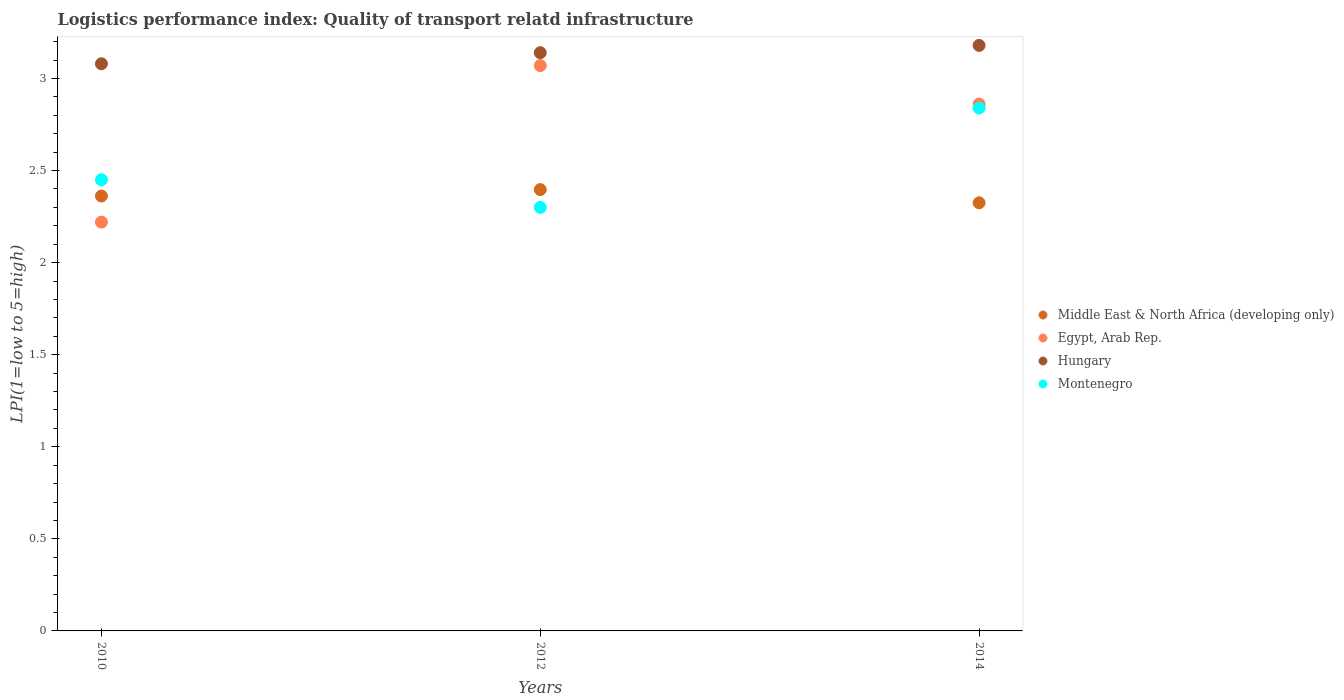How many different coloured dotlines are there?
Keep it short and to the point. 4. What is the logistics performance index in Hungary in 2010?
Provide a short and direct response. 3.08. Across all years, what is the maximum logistics performance index in Montenegro?
Offer a very short reply. 2.84. Across all years, what is the minimum logistics performance index in Middle East & North Africa (developing only)?
Provide a short and direct response. 2.32. In which year was the logistics performance index in Egypt, Arab Rep. minimum?
Your answer should be compact. 2010. What is the total logistics performance index in Hungary in the graph?
Ensure brevity in your answer.  9.4. What is the difference between the logistics performance index in Middle East & North Africa (developing only) in 2010 and that in 2012?
Keep it short and to the point. -0.03. What is the difference between the logistics performance index in Hungary in 2012 and the logistics performance index in Middle East & North Africa (developing only) in 2010?
Your answer should be very brief. 0.78. What is the average logistics performance index in Middle East & North Africa (developing only) per year?
Your answer should be very brief. 2.36. In the year 2010, what is the difference between the logistics performance index in Montenegro and logistics performance index in Egypt, Arab Rep.?
Offer a very short reply. 0.23. In how many years, is the logistics performance index in Montenegro greater than 1.7?
Your answer should be very brief. 3. What is the ratio of the logistics performance index in Montenegro in 2012 to that in 2014?
Ensure brevity in your answer.  0.81. Is the logistics performance index in Hungary in 2012 less than that in 2014?
Your answer should be very brief. Yes. Is the difference between the logistics performance index in Montenegro in 2012 and 2014 greater than the difference between the logistics performance index in Egypt, Arab Rep. in 2012 and 2014?
Ensure brevity in your answer.  No. What is the difference between the highest and the second highest logistics performance index in Hungary?
Keep it short and to the point. 0.04. What is the difference between the highest and the lowest logistics performance index in Montenegro?
Offer a terse response. 0.54. In how many years, is the logistics performance index in Middle East & North Africa (developing only) greater than the average logistics performance index in Middle East & North Africa (developing only) taken over all years?
Ensure brevity in your answer.  2. Does the logistics performance index in Middle East & North Africa (developing only) monotonically increase over the years?
Provide a short and direct response. No. Is the logistics performance index in Hungary strictly greater than the logistics performance index in Montenegro over the years?
Ensure brevity in your answer.  Yes. Is the logistics performance index in Hungary strictly less than the logistics performance index in Egypt, Arab Rep. over the years?
Your answer should be compact. No. How many years are there in the graph?
Ensure brevity in your answer.  3. Does the graph contain grids?
Provide a succinct answer. No. How are the legend labels stacked?
Provide a succinct answer. Vertical. What is the title of the graph?
Your response must be concise. Logistics performance index: Quality of transport relatd infrastructure. Does "Czech Republic" appear as one of the legend labels in the graph?
Your response must be concise. No. What is the label or title of the Y-axis?
Your answer should be compact. LPI(1=low to 5=high). What is the LPI(1=low to 5=high) in Middle East & North Africa (developing only) in 2010?
Your answer should be very brief. 2.36. What is the LPI(1=low to 5=high) of Egypt, Arab Rep. in 2010?
Your answer should be very brief. 2.22. What is the LPI(1=low to 5=high) in Hungary in 2010?
Make the answer very short. 3.08. What is the LPI(1=low to 5=high) of Montenegro in 2010?
Provide a short and direct response. 2.45. What is the LPI(1=low to 5=high) of Middle East & North Africa (developing only) in 2012?
Provide a succinct answer. 2.4. What is the LPI(1=low to 5=high) in Egypt, Arab Rep. in 2012?
Your response must be concise. 3.07. What is the LPI(1=low to 5=high) of Hungary in 2012?
Provide a succinct answer. 3.14. What is the LPI(1=low to 5=high) of Montenegro in 2012?
Your answer should be compact. 2.3. What is the LPI(1=low to 5=high) of Middle East & North Africa (developing only) in 2014?
Provide a short and direct response. 2.32. What is the LPI(1=low to 5=high) of Egypt, Arab Rep. in 2014?
Provide a short and direct response. 2.86. What is the LPI(1=low to 5=high) in Hungary in 2014?
Your answer should be compact. 3.18. What is the LPI(1=low to 5=high) of Montenegro in 2014?
Offer a very short reply. 2.84. Across all years, what is the maximum LPI(1=low to 5=high) in Middle East & North Africa (developing only)?
Offer a terse response. 2.4. Across all years, what is the maximum LPI(1=low to 5=high) in Egypt, Arab Rep.?
Give a very brief answer. 3.07. Across all years, what is the maximum LPI(1=low to 5=high) of Hungary?
Make the answer very short. 3.18. Across all years, what is the maximum LPI(1=low to 5=high) of Montenegro?
Your answer should be very brief. 2.84. Across all years, what is the minimum LPI(1=low to 5=high) of Middle East & North Africa (developing only)?
Offer a terse response. 2.32. Across all years, what is the minimum LPI(1=low to 5=high) in Egypt, Arab Rep.?
Provide a succinct answer. 2.22. Across all years, what is the minimum LPI(1=low to 5=high) in Hungary?
Offer a very short reply. 3.08. What is the total LPI(1=low to 5=high) of Middle East & North Africa (developing only) in the graph?
Offer a very short reply. 7.08. What is the total LPI(1=low to 5=high) of Egypt, Arab Rep. in the graph?
Give a very brief answer. 8.15. What is the total LPI(1=low to 5=high) in Hungary in the graph?
Your answer should be compact. 9.4. What is the total LPI(1=low to 5=high) of Montenegro in the graph?
Offer a very short reply. 7.59. What is the difference between the LPI(1=low to 5=high) of Middle East & North Africa (developing only) in 2010 and that in 2012?
Offer a terse response. -0.03. What is the difference between the LPI(1=low to 5=high) of Egypt, Arab Rep. in 2010 and that in 2012?
Keep it short and to the point. -0.85. What is the difference between the LPI(1=low to 5=high) in Hungary in 2010 and that in 2012?
Provide a succinct answer. -0.06. What is the difference between the LPI(1=low to 5=high) of Montenegro in 2010 and that in 2012?
Your response must be concise. 0.15. What is the difference between the LPI(1=low to 5=high) of Middle East & North Africa (developing only) in 2010 and that in 2014?
Your answer should be very brief. 0.04. What is the difference between the LPI(1=low to 5=high) in Egypt, Arab Rep. in 2010 and that in 2014?
Your response must be concise. -0.64. What is the difference between the LPI(1=low to 5=high) in Hungary in 2010 and that in 2014?
Offer a very short reply. -0.1. What is the difference between the LPI(1=low to 5=high) in Montenegro in 2010 and that in 2014?
Keep it short and to the point. -0.39. What is the difference between the LPI(1=low to 5=high) in Middle East & North Africa (developing only) in 2012 and that in 2014?
Give a very brief answer. 0.07. What is the difference between the LPI(1=low to 5=high) of Egypt, Arab Rep. in 2012 and that in 2014?
Ensure brevity in your answer.  0.21. What is the difference between the LPI(1=low to 5=high) of Hungary in 2012 and that in 2014?
Keep it short and to the point. -0.04. What is the difference between the LPI(1=low to 5=high) of Montenegro in 2012 and that in 2014?
Provide a succinct answer. -0.54. What is the difference between the LPI(1=low to 5=high) of Middle East & North Africa (developing only) in 2010 and the LPI(1=low to 5=high) of Egypt, Arab Rep. in 2012?
Offer a very short reply. -0.71. What is the difference between the LPI(1=low to 5=high) in Middle East & North Africa (developing only) in 2010 and the LPI(1=low to 5=high) in Hungary in 2012?
Keep it short and to the point. -0.78. What is the difference between the LPI(1=low to 5=high) of Middle East & North Africa (developing only) in 2010 and the LPI(1=low to 5=high) of Montenegro in 2012?
Provide a short and direct response. 0.06. What is the difference between the LPI(1=low to 5=high) in Egypt, Arab Rep. in 2010 and the LPI(1=low to 5=high) in Hungary in 2012?
Offer a terse response. -0.92. What is the difference between the LPI(1=low to 5=high) of Egypt, Arab Rep. in 2010 and the LPI(1=low to 5=high) of Montenegro in 2012?
Your answer should be compact. -0.08. What is the difference between the LPI(1=low to 5=high) of Hungary in 2010 and the LPI(1=low to 5=high) of Montenegro in 2012?
Provide a short and direct response. 0.78. What is the difference between the LPI(1=low to 5=high) of Middle East & North Africa (developing only) in 2010 and the LPI(1=low to 5=high) of Egypt, Arab Rep. in 2014?
Make the answer very short. -0.5. What is the difference between the LPI(1=low to 5=high) of Middle East & North Africa (developing only) in 2010 and the LPI(1=low to 5=high) of Hungary in 2014?
Provide a short and direct response. -0.82. What is the difference between the LPI(1=low to 5=high) in Middle East & North Africa (developing only) in 2010 and the LPI(1=low to 5=high) in Montenegro in 2014?
Give a very brief answer. -0.48. What is the difference between the LPI(1=low to 5=high) in Egypt, Arab Rep. in 2010 and the LPI(1=low to 5=high) in Hungary in 2014?
Keep it short and to the point. -0.96. What is the difference between the LPI(1=low to 5=high) of Egypt, Arab Rep. in 2010 and the LPI(1=low to 5=high) of Montenegro in 2014?
Make the answer very short. -0.62. What is the difference between the LPI(1=low to 5=high) of Hungary in 2010 and the LPI(1=low to 5=high) of Montenegro in 2014?
Provide a short and direct response. 0.24. What is the difference between the LPI(1=low to 5=high) in Middle East & North Africa (developing only) in 2012 and the LPI(1=low to 5=high) in Egypt, Arab Rep. in 2014?
Offer a terse response. -0.46. What is the difference between the LPI(1=low to 5=high) of Middle East & North Africa (developing only) in 2012 and the LPI(1=low to 5=high) of Hungary in 2014?
Offer a terse response. -0.78. What is the difference between the LPI(1=low to 5=high) in Middle East & North Africa (developing only) in 2012 and the LPI(1=low to 5=high) in Montenegro in 2014?
Make the answer very short. -0.44. What is the difference between the LPI(1=low to 5=high) in Egypt, Arab Rep. in 2012 and the LPI(1=low to 5=high) in Hungary in 2014?
Offer a terse response. -0.11. What is the difference between the LPI(1=low to 5=high) in Egypt, Arab Rep. in 2012 and the LPI(1=low to 5=high) in Montenegro in 2014?
Your response must be concise. 0.23. What is the difference between the LPI(1=low to 5=high) of Hungary in 2012 and the LPI(1=low to 5=high) of Montenegro in 2014?
Your answer should be compact. 0.3. What is the average LPI(1=low to 5=high) in Middle East & North Africa (developing only) per year?
Give a very brief answer. 2.36. What is the average LPI(1=low to 5=high) in Egypt, Arab Rep. per year?
Your response must be concise. 2.72. What is the average LPI(1=low to 5=high) of Hungary per year?
Offer a very short reply. 3.13. What is the average LPI(1=low to 5=high) in Montenegro per year?
Your answer should be compact. 2.53. In the year 2010, what is the difference between the LPI(1=low to 5=high) of Middle East & North Africa (developing only) and LPI(1=low to 5=high) of Egypt, Arab Rep.?
Your answer should be compact. 0.14. In the year 2010, what is the difference between the LPI(1=low to 5=high) of Middle East & North Africa (developing only) and LPI(1=low to 5=high) of Hungary?
Your answer should be compact. -0.72. In the year 2010, what is the difference between the LPI(1=low to 5=high) of Middle East & North Africa (developing only) and LPI(1=low to 5=high) of Montenegro?
Offer a very short reply. -0.09. In the year 2010, what is the difference between the LPI(1=low to 5=high) in Egypt, Arab Rep. and LPI(1=low to 5=high) in Hungary?
Ensure brevity in your answer.  -0.86. In the year 2010, what is the difference between the LPI(1=low to 5=high) in Egypt, Arab Rep. and LPI(1=low to 5=high) in Montenegro?
Give a very brief answer. -0.23. In the year 2010, what is the difference between the LPI(1=low to 5=high) in Hungary and LPI(1=low to 5=high) in Montenegro?
Provide a succinct answer. 0.63. In the year 2012, what is the difference between the LPI(1=low to 5=high) in Middle East & North Africa (developing only) and LPI(1=low to 5=high) in Egypt, Arab Rep.?
Keep it short and to the point. -0.67. In the year 2012, what is the difference between the LPI(1=low to 5=high) of Middle East & North Africa (developing only) and LPI(1=low to 5=high) of Hungary?
Offer a very short reply. -0.74. In the year 2012, what is the difference between the LPI(1=low to 5=high) in Middle East & North Africa (developing only) and LPI(1=low to 5=high) in Montenegro?
Provide a short and direct response. 0.1. In the year 2012, what is the difference between the LPI(1=low to 5=high) in Egypt, Arab Rep. and LPI(1=low to 5=high) in Hungary?
Make the answer very short. -0.07. In the year 2012, what is the difference between the LPI(1=low to 5=high) in Egypt, Arab Rep. and LPI(1=low to 5=high) in Montenegro?
Offer a very short reply. 0.77. In the year 2012, what is the difference between the LPI(1=low to 5=high) in Hungary and LPI(1=low to 5=high) in Montenegro?
Ensure brevity in your answer.  0.84. In the year 2014, what is the difference between the LPI(1=low to 5=high) in Middle East & North Africa (developing only) and LPI(1=low to 5=high) in Egypt, Arab Rep.?
Your answer should be compact. -0.54. In the year 2014, what is the difference between the LPI(1=low to 5=high) of Middle East & North Africa (developing only) and LPI(1=low to 5=high) of Hungary?
Your answer should be compact. -0.85. In the year 2014, what is the difference between the LPI(1=low to 5=high) of Middle East & North Africa (developing only) and LPI(1=low to 5=high) of Montenegro?
Make the answer very short. -0.51. In the year 2014, what is the difference between the LPI(1=low to 5=high) of Egypt, Arab Rep. and LPI(1=low to 5=high) of Hungary?
Give a very brief answer. -0.32. In the year 2014, what is the difference between the LPI(1=low to 5=high) in Egypt, Arab Rep. and LPI(1=low to 5=high) in Montenegro?
Your answer should be very brief. 0.02. In the year 2014, what is the difference between the LPI(1=low to 5=high) in Hungary and LPI(1=low to 5=high) in Montenegro?
Ensure brevity in your answer.  0.34. What is the ratio of the LPI(1=low to 5=high) of Middle East & North Africa (developing only) in 2010 to that in 2012?
Make the answer very short. 0.99. What is the ratio of the LPI(1=low to 5=high) of Egypt, Arab Rep. in 2010 to that in 2012?
Offer a very short reply. 0.72. What is the ratio of the LPI(1=low to 5=high) in Hungary in 2010 to that in 2012?
Offer a terse response. 0.98. What is the ratio of the LPI(1=low to 5=high) of Montenegro in 2010 to that in 2012?
Keep it short and to the point. 1.07. What is the ratio of the LPI(1=low to 5=high) in Middle East & North Africa (developing only) in 2010 to that in 2014?
Make the answer very short. 1.02. What is the ratio of the LPI(1=low to 5=high) in Egypt, Arab Rep. in 2010 to that in 2014?
Offer a very short reply. 0.78. What is the ratio of the LPI(1=low to 5=high) in Hungary in 2010 to that in 2014?
Make the answer very short. 0.97. What is the ratio of the LPI(1=low to 5=high) in Montenegro in 2010 to that in 2014?
Offer a very short reply. 0.86. What is the ratio of the LPI(1=low to 5=high) of Middle East & North Africa (developing only) in 2012 to that in 2014?
Your answer should be very brief. 1.03. What is the ratio of the LPI(1=low to 5=high) in Egypt, Arab Rep. in 2012 to that in 2014?
Your response must be concise. 1.07. What is the ratio of the LPI(1=low to 5=high) in Hungary in 2012 to that in 2014?
Your answer should be compact. 0.99. What is the ratio of the LPI(1=low to 5=high) of Montenegro in 2012 to that in 2014?
Make the answer very short. 0.81. What is the difference between the highest and the second highest LPI(1=low to 5=high) in Middle East & North Africa (developing only)?
Your answer should be compact. 0.03. What is the difference between the highest and the second highest LPI(1=low to 5=high) of Egypt, Arab Rep.?
Make the answer very short. 0.21. What is the difference between the highest and the second highest LPI(1=low to 5=high) of Hungary?
Your answer should be very brief. 0.04. What is the difference between the highest and the second highest LPI(1=low to 5=high) of Montenegro?
Your response must be concise. 0.39. What is the difference between the highest and the lowest LPI(1=low to 5=high) of Middle East & North Africa (developing only)?
Keep it short and to the point. 0.07. What is the difference between the highest and the lowest LPI(1=low to 5=high) of Hungary?
Your response must be concise. 0.1. What is the difference between the highest and the lowest LPI(1=low to 5=high) of Montenegro?
Keep it short and to the point. 0.54. 